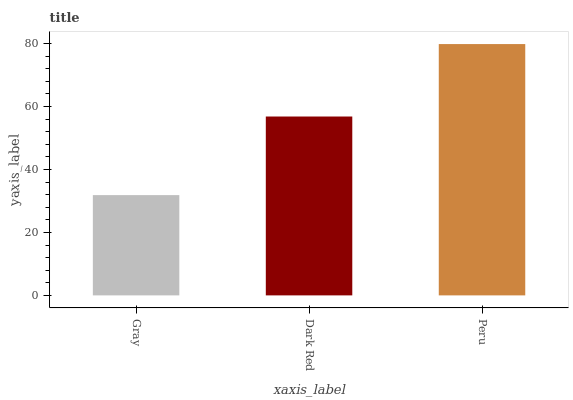Is Gray the minimum?
Answer yes or no. Yes. Is Peru the maximum?
Answer yes or no. Yes. Is Dark Red the minimum?
Answer yes or no. No. Is Dark Red the maximum?
Answer yes or no. No. Is Dark Red greater than Gray?
Answer yes or no. Yes. Is Gray less than Dark Red?
Answer yes or no. Yes. Is Gray greater than Dark Red?
Answer yes or no. No. Is Dark Red less than Gray?
Answer yes or no. No. Is Dark Red the high median?
Answer yes or no. Yes. Is Dark Red the low median?
Answer yes or no. Yes. Is Gray the high median?
Answer yes or no. No. Is Gray the low median?
Answer yes or no. No. 